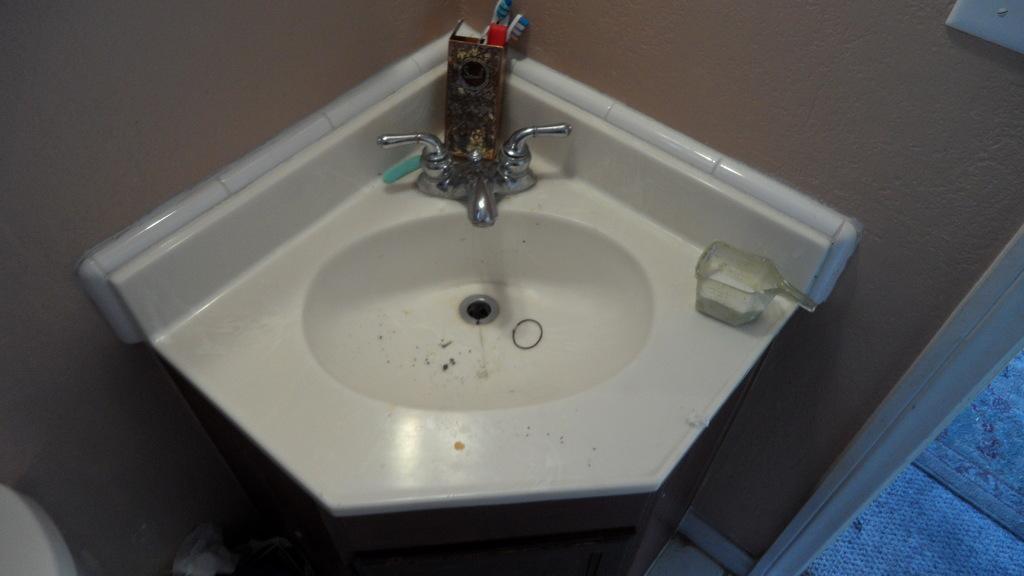Can you describe this image briefly? In the image we can see there is a handwash sink and there are brushes kept in the stand. There is a mug kept on the hand wash sink and there is a door. 